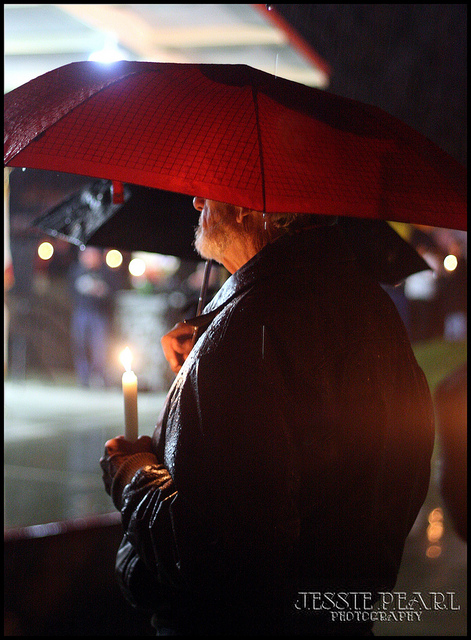Extract all visible text content from this image. JESSIE PEL PHOTOGRAPHY 